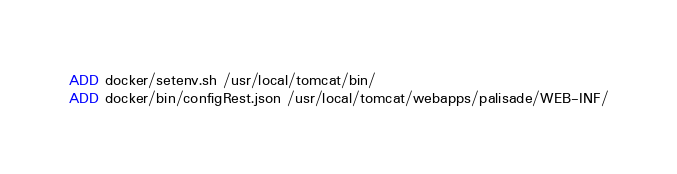<code> <loc_0><loc_0><loc_500><loc_500><_Dockerfile_>ADD docker/setenv.sh /usr/local/tomcat/bin/
ADD docker/bin/configRest.json /usr/local/tomcat/webapps/palisade/WEB-INF/

</code> 